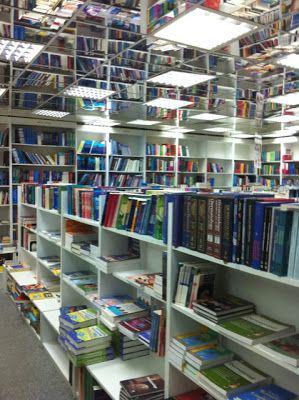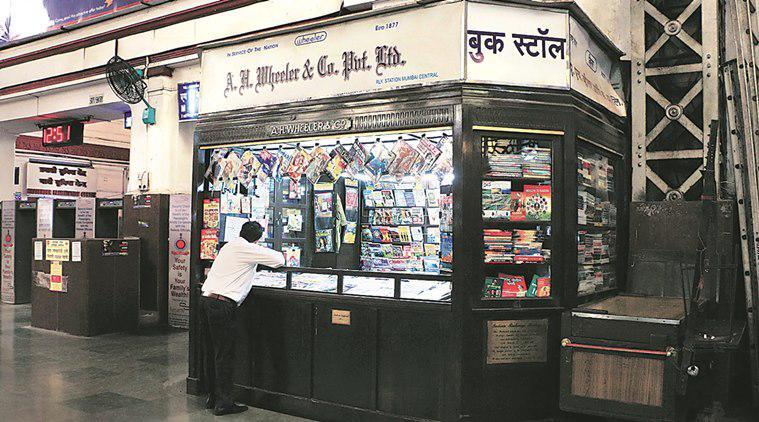The first image is the image on the left, the second image is the image on the right. Given the left and right images, does the statement "People are seen enjoying books in a bookstore." hold true? Answer yes or no. No. The first image is the image on the left, the second image is the image on the right. For the images shown, is this caption "There is a person behind the counter of a bookstore that has at least four separate bookshelves." true? Answer yes or no. No. 